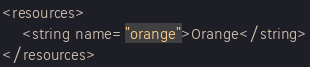Convert code to text. <code><loc_0><loc_0><loc_500><loc_500><_XML_><resources>
    <string name="orange">Orange</string>
</resources>
</code> 